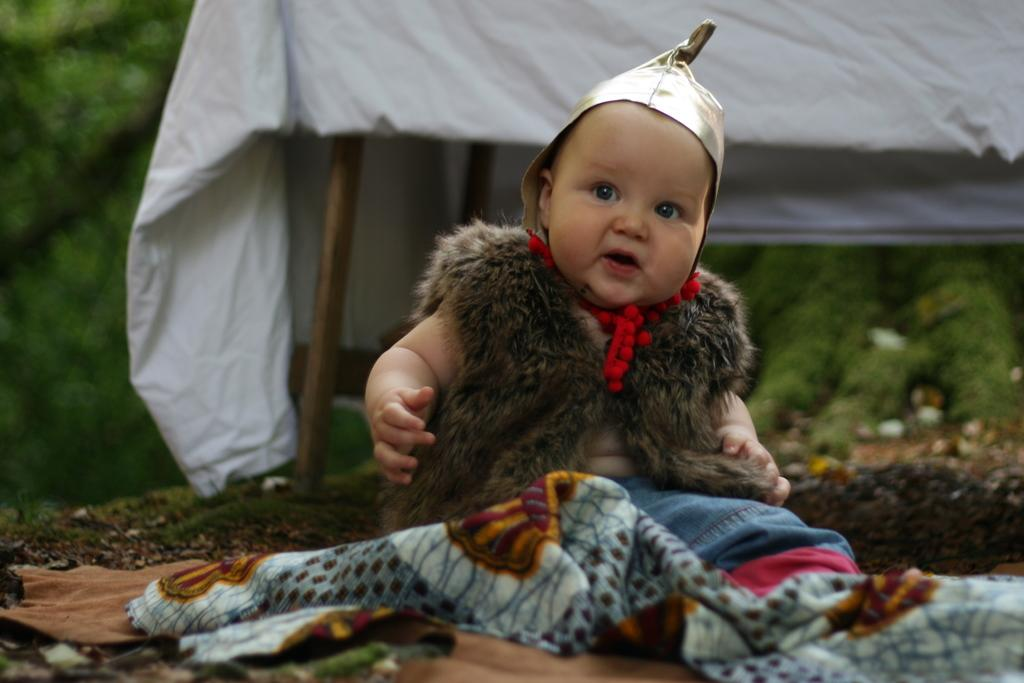What is the main subject in the image? There is a child in the middle of the image. What can be observed about the child's attire? The child is wearing clothes. What structure is visible in the background of the image? There is a tent visible in the background of the image. What type of lace is used to decorate the child's outfit in the image? There is no mention of lace or any specific decorations on the child's outfit in the image. 